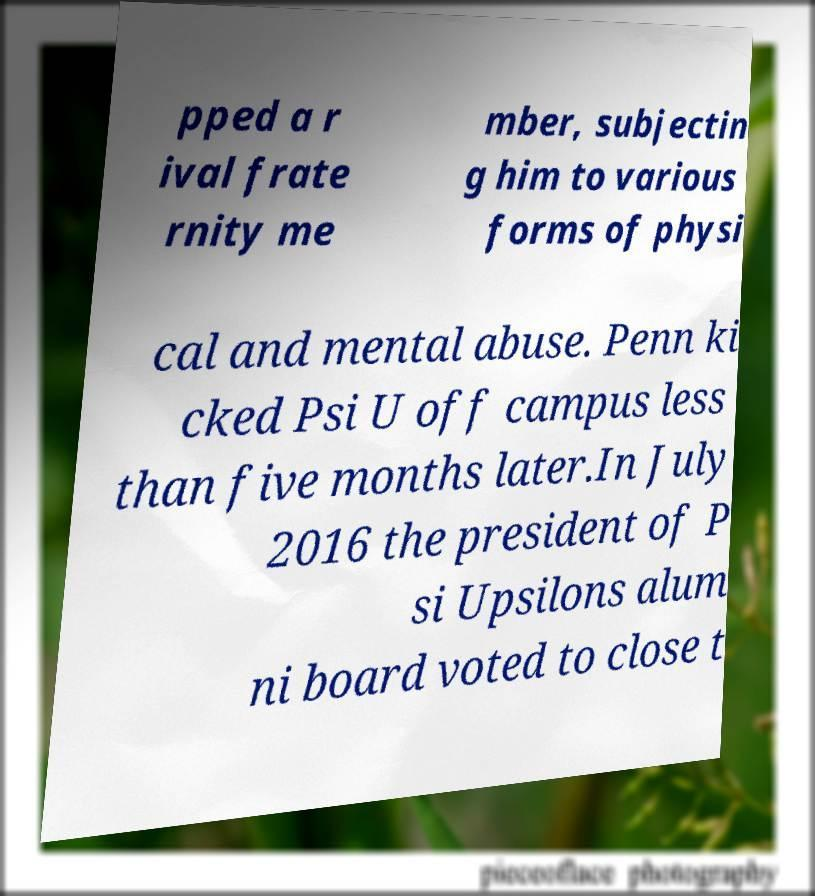Can you read and provide the text displayed in the image?This photo seems to have some interesting text. Can you extract and type it out for me? pped a r ival frate rnity me mber, subjectin g him to various forms of physi cal and mental abuse. Penn ki cked Psi U off campus less than five months later.In July 2016 the president of P si Upsilons alum ni board voted to close t 